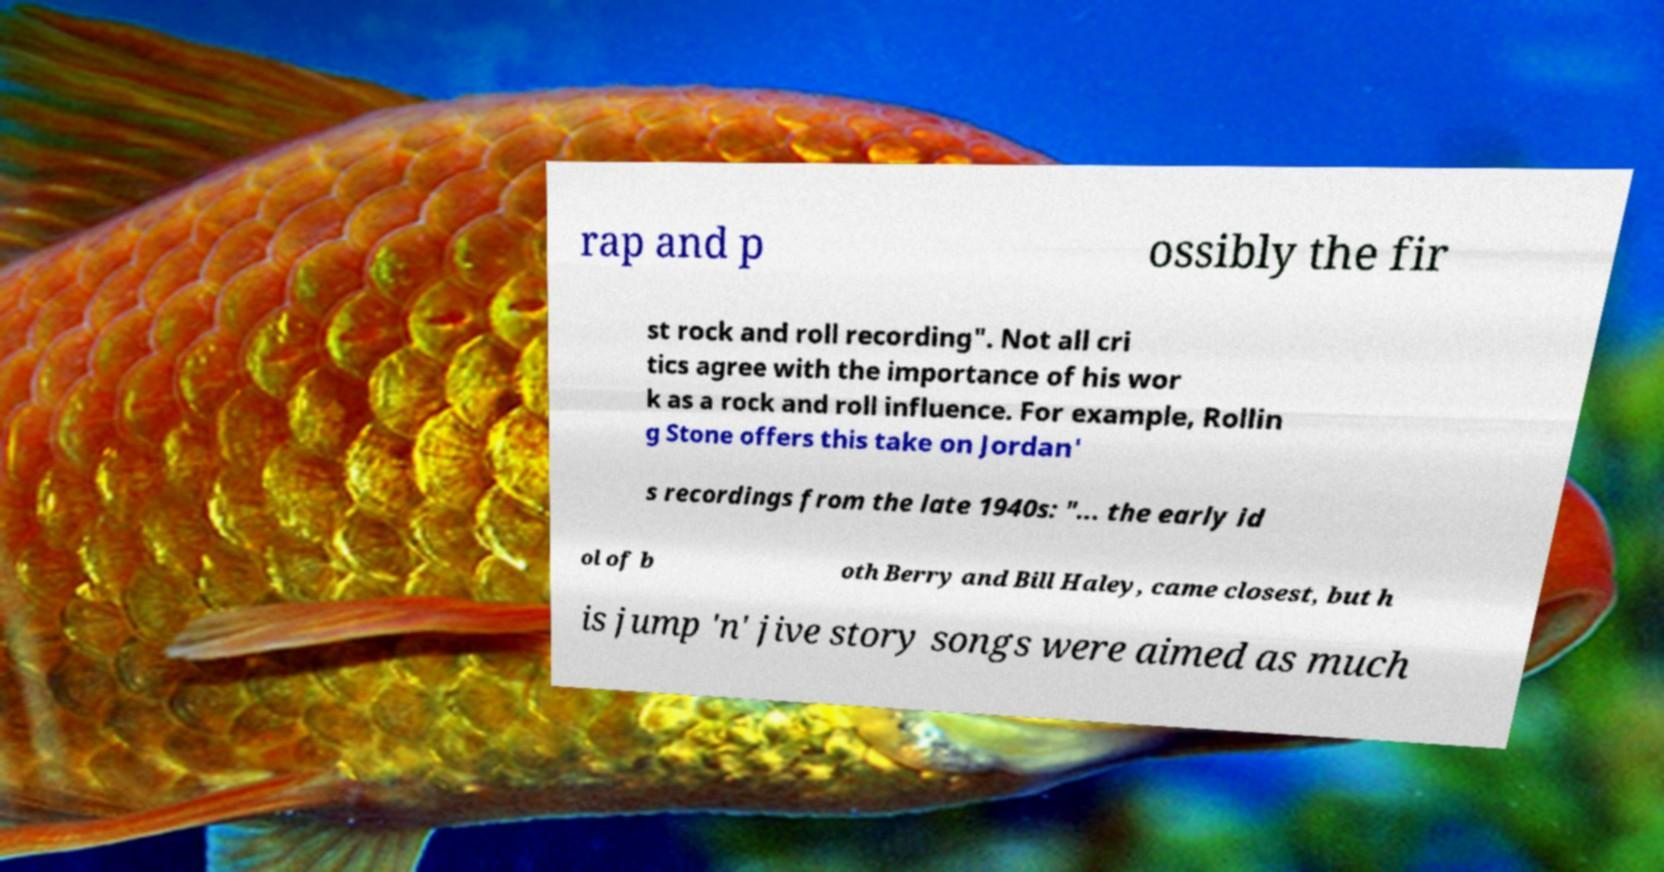Can you read and provide the text displayed in the image?This photo seems to have some interesting text. Can you extract and type it out for me? rap and p ossibly the fir st rock and roll recording". Not all cri tics agree with the importance of his wor k as a rock and roll influence. For example, Rollin g Stone offers this take on Jordan' s recordings from the late 1940s: "... the early id ol of b oth Berry and Bill Haley, came closest, but h is jump 'n' jive story songs were aimed as much 